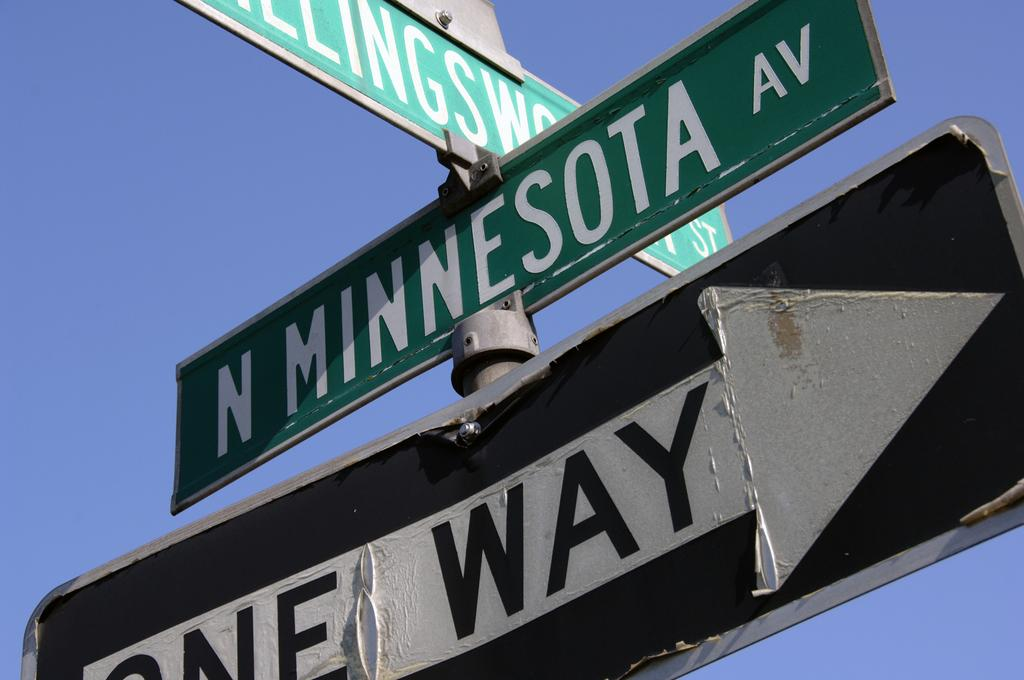<image>
Provide a brief description of the given image. Signs on a pole including one that says ONE WAY. 